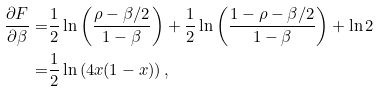<formula> <loc_0><loc_0><loc_500><loc_500>\frac { \partial F } { \partial \beta } = & \frac { 1 } { 2 } \ln \left ( \frac { \rho - \beta / 2 } { 1 - \beta } \right ) + \frac { 1 } { 2 } \ln \left ( \frac { 1 - \rho - \beta / 2 } { 1 - \beta } \right ) + \ln 2 \\ = & \frac { 1 } { 2 } \ln \left ( 4 x ( 1 - x ) \right ) ,</formula> 